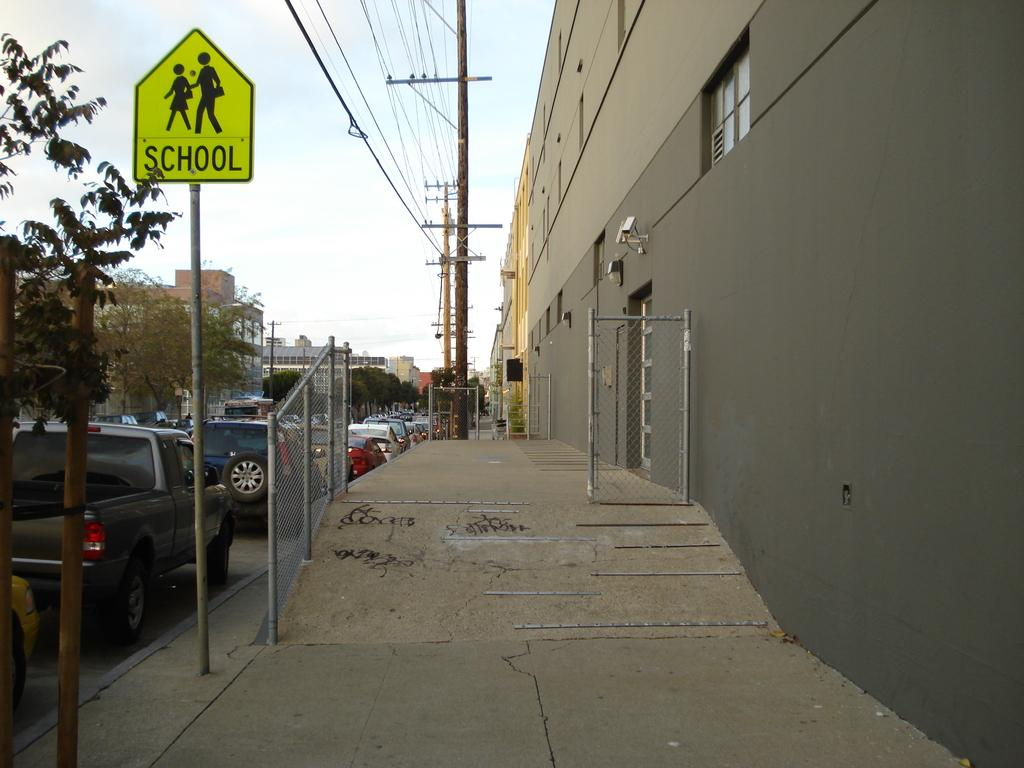<image>
Provide a brief description of the given image. A pedestrian crossing sign has the word "school" on it. 